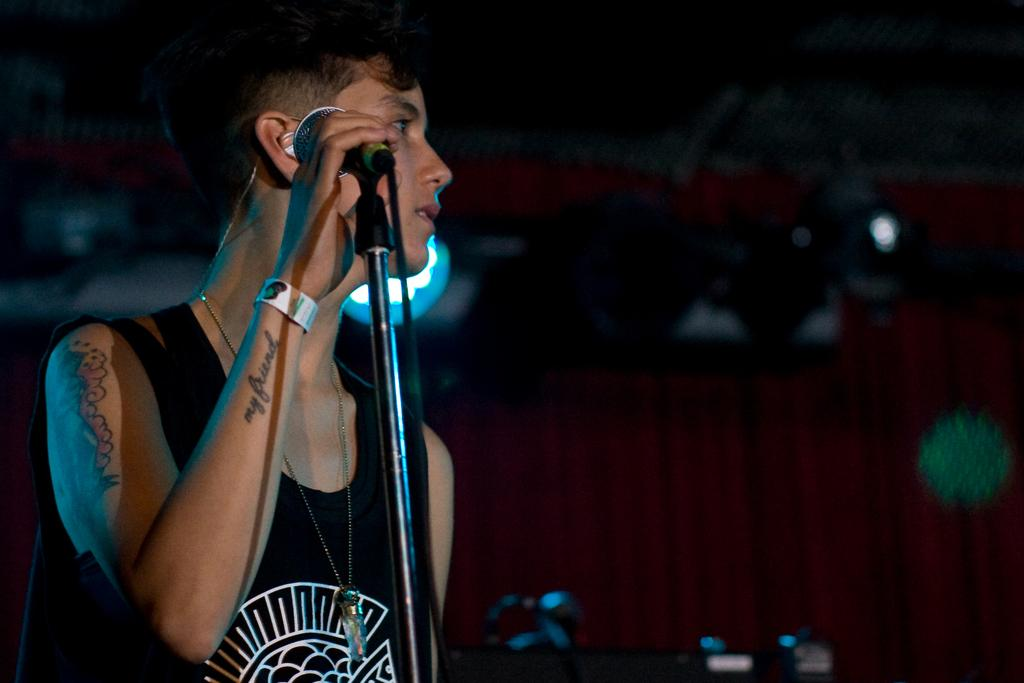What is the main subject of the image? The main subject of the image is a man. What is the man doing in the image? The man is standing in the image. What object is the man holding in the image? The man is holding a microphone in the image. What color is the top that the man is wearing? The man is wearing a black color top. What additional feature can be observed on the man's body? The man has tattoos on his body. How many pies are being served on the table in the image? There is no table or pies present in the image; it features a man holding a microphone. What is the mass of the microphone that the man is holding? The mass of the microphone cannot be determined from the image alone. 